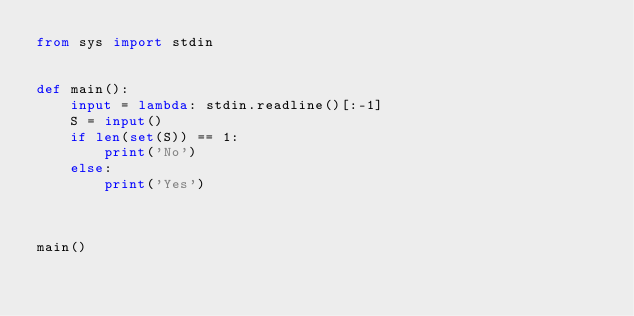<code> <loc_0><loc_0><loc_500><loc_500><_Python_>from sys import stdin


def main():
    input = lambda: stdin.readline()[:-1]
    S = input()
    if len(set(S)) == 1:
        print('No')
    else:
        print('Yes')



main()
</code> 